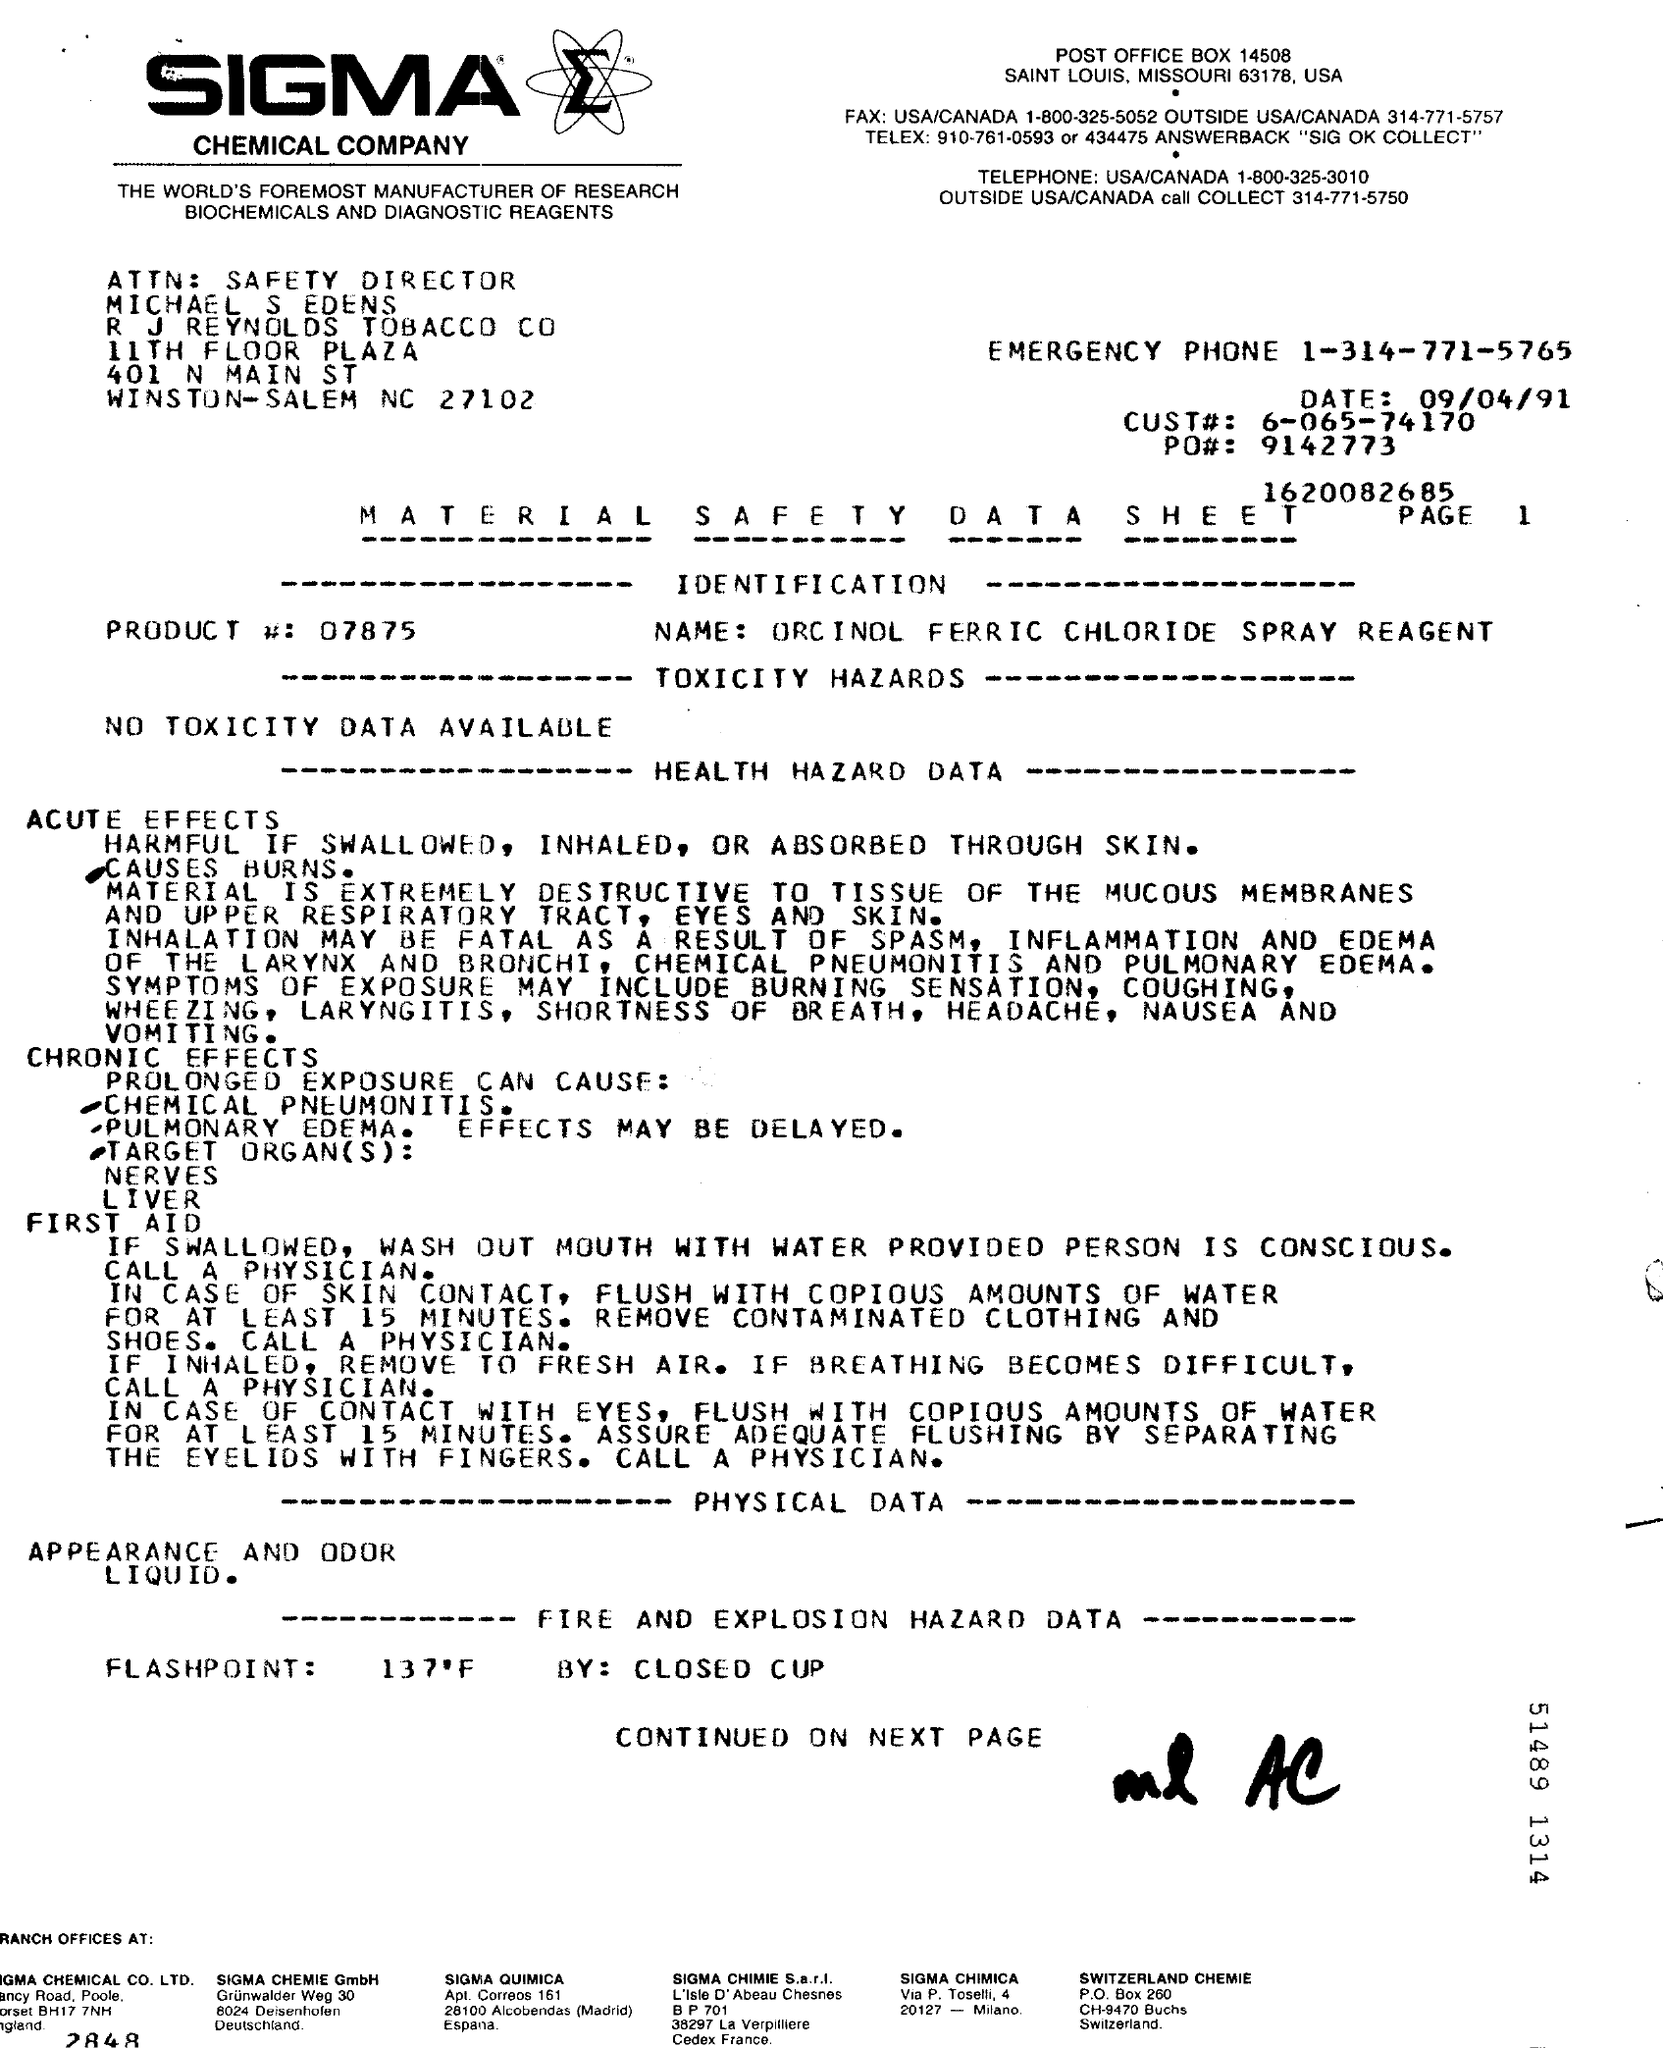Which company's Material Safety Data Sheet is this?
Your answer should be compact. SIGMA CHEMICAL COMPANY. What is the Product Name mentioned in the document?
Keep it short and to the point. ORCINOL FERRIC CHLORIDE SPRAY REAGENT. What is the Product # given in the document?
Your answer should be very brief. 07875. What is the CUST# given in the document?
Keep it short and to the point. 6-065-74170. Who is the Safety Director of R J Reynolds Tobacco Co?
Your answer should be very brief. Michael S Edens. 